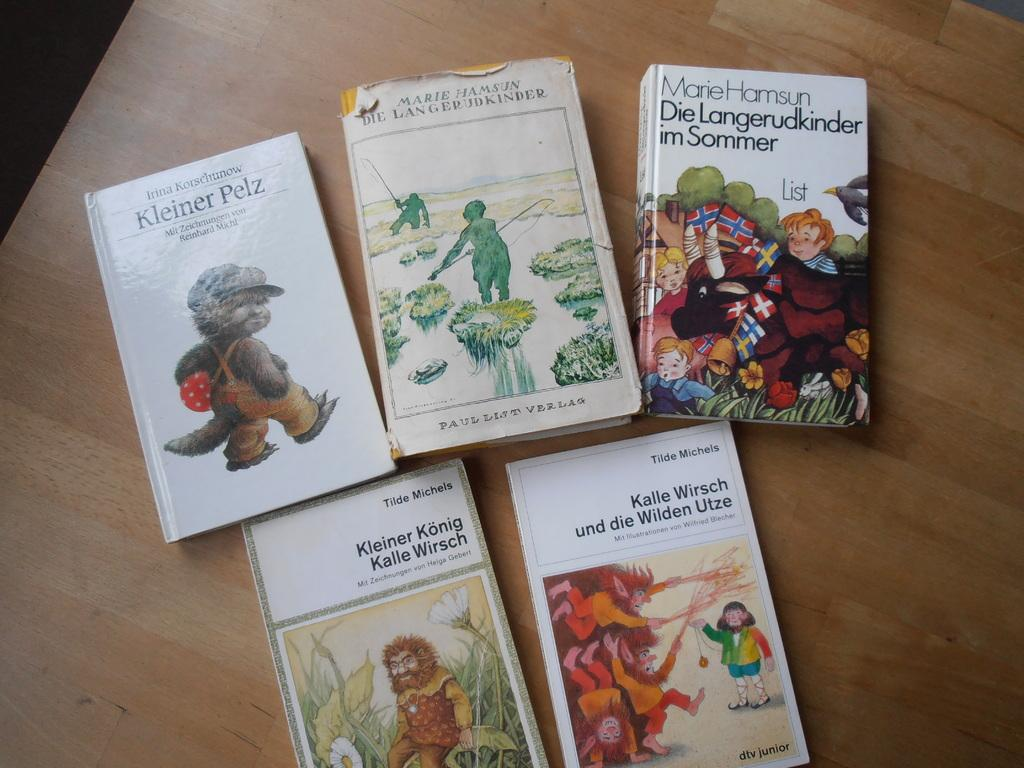<image>
Write a terse but informative summary of the picture. five different childrens' books by different authors like Kalle Wirsch and Marie Hamsun. 